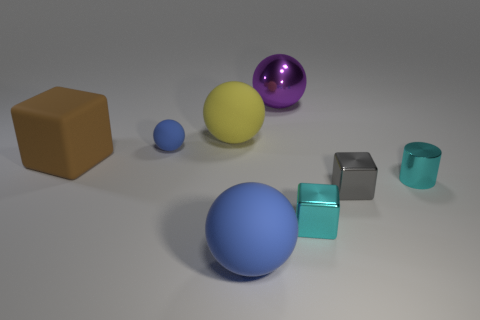Add 1 tiny cylinders. How many objects exist? 9 Subtract all cubes. How many objects are left? 5 Add 3 gray things. How many gray things are left? 4 Add 3 small objects. How many small objects exist? 7 Subtract 0 red spheres. How many objects are left? 8 Subtract all tiny red objects. Subtract all big shiny things. How many objects are left? 7 